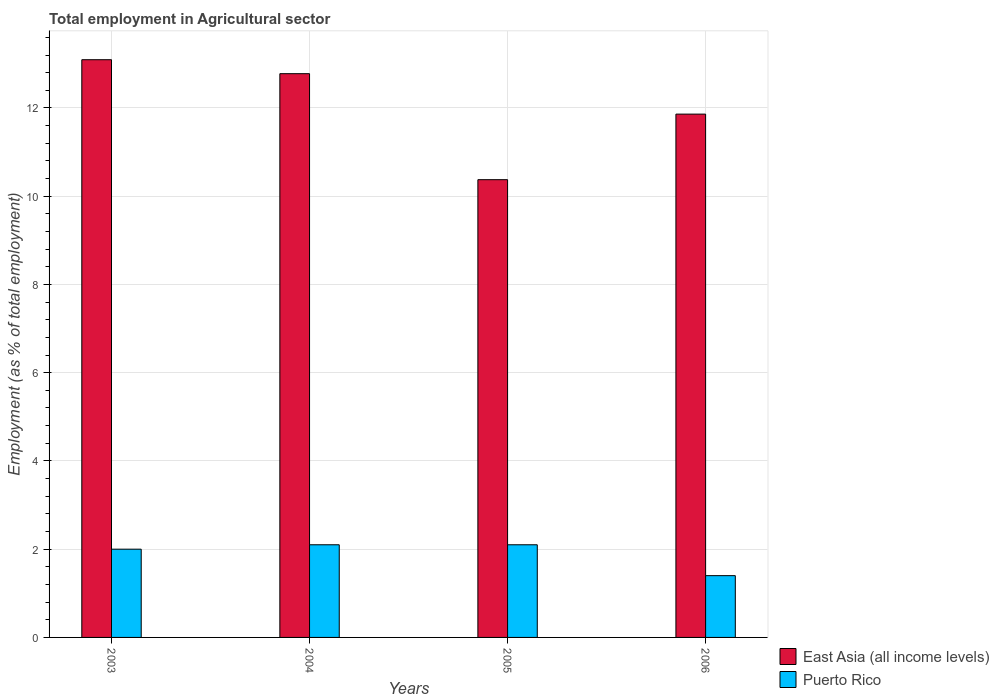How many groups of bars are there?
Give a very brief answer. 4. Are the number of bars on each tick of the X-axis equal?
Offer a very short reply. Yes. How many bars are there on the 4th tick from the left?
Your answer should be very brief. 2. How many bars are there on the 2nd tick from the right?
Offer a terse response. 2. What is the label of the 4th group of bars from the left?
Provide a succinct answer. 2006. What is the employment in agricultural sector in Puerto Rico in 2004?
Provide a short and direct response. 2.1. Across all years, what is the maximum employment in agricultural sector in East Asia (all income levels)?
Provide a short and direct response. 13.09. Across all years, what is the minimum employment in agricultural sector in Puerto Rico?
Ensure brevity in your answer.  1.4. In which year was the employment in agricultural sector in East Asia (all income levels) minimum?
Make the answer very short. 2005. What is the total employment in agricultural sector in East Asia (all income levels) in the graph?
Your answer should be very brief. 48.11. What is the difference between the employment in agricultural sector in Puerto Rico in 2004 and that in 2006?
Your response must be concise. 0.7. What is the difference between the employment in agricultural sector in Puerto Rico in 2005 and the employment in agricultural sector in East Asia (all income levels) in 2004?
Keep it short and to the point. -10.68. What is the average employment in agricultural sector in Puerto Rico per year?
Ensure brevity in your answer.  1.9. In the year 2005, what is the difference between the employment in agricultural sector in East Asia (all income levels) and employment in agricultural sector in Puerto Rico?
Make the answer very short. 8.27. In how many years, is the employment in agricultural sector in East Asia (all income levels) greater than 8.4 %?
Give a very brief answer. 4. What is the ratio of the employment in agricultural sector in East Asia (all income levels) in 2003 to that in 2006?
Provide a short and direct response. 1.1. Is the employment in agricultural sector in East Asia (all income levels) in 2004 less than that in 2006?
Offer a terse response. No. What is the difference between the highest and the second highest employment in agricultural sector in East Asia (all income levels)?
Give a very brief answer. 0.32. What is the difference between the highest and the lowest employment in agricultural sector in East Asia (all income levels)?
Ensure brevity in your answer.  2.72. In how many years, is the employment in agricultural sector in Puerto Rico greater than the average employment in agricultural sector in Puerto Rico taken over all years?
Keep it short and to the point. 3. Is the sum of the employment in agricultural sector in Puerto Rico in 2004 and 2006 greater than the maximum employment in agricultural sector in East Asia (all income levels) across all years?
Your answer should be very brief. No. What does the 2nd bar from the left in 2006 represents?
Keep it short and to the point. Puerto Rico. What does the 2nd bar from the right in 2003 represents?
Provide a short and direct response. East Asia (all income levels). How many years are there in the graph?
Offer a terse response. 4. Does the graph contain grids?
Provide a short and direct response. Yes. Where does the legend appear in the graph?
Your response must be concise. Bottom right. How many legend labels are there?
Your response must be concise. 2. How are the legend labels stacked?
Provide a short and direct response. Vertical. What is the title of the graph?
Give a very brief answer. Total employment in Agricultural sector. What is the label or title of the X-axis?
Your response must be concise. Years. What is the label or title of the Y-axis?
Make the answer very short. Employment (as % of total employment). What is the Employment (as % of total employment) of East Asia (all income levels) in 2003?
Make the answer very short. 13.09. What is the Employment (as % of total employment) of Puerto Rico in 2003?
Your answer should be very brief. 2. What is the Employment (as % of total employment) in East Asia (all income levels) in 2004?
Offer a terse response. 12.78. What is the Employment (as % of total employment) in Puerto Rico in 2004?
Offer a very short reply. 2.1. What is the Employment (as % of total employment) in East Asia (all income levels) in 2005?
Your response must be concise. 10.37. What is the Employment (as % of total employment) in Puerto Rico in 2005?
Your answer should be compact. 2.1. What is the Employment (as % of total employment) of East Asia (all income levels) in 2006?
Keep it short and to the point. 11.86. What is the Employment (as % of total employment) of Puerto Rico in 2006?
Your response must be concise. 1.4. Across all years, what is the maximum Employment (as % of total employment) of East Asia (all income levels)?
Offer a terse response. 13.09. Across all years, what is the maximum Employment (as % of total employment) in Puerto Rico?
Your answer should be compact. 2.1. Across all years, what is the minimum Employment (as % of total employment) of East Asia (all income levels)?
Offer a very short reply. 10.37. Across all years, what is the minimum Employment (as % of total employment) in Puerto Rico?
Your response must be concise. 1.4. What is the total Employment (as % of total employment) of East Asia (all income levels) in the graph?
Your answer should be compact. 48.11. What is the difference between the Employment (as % of total employment) of East Asia (all income levels) in 2003 and that in 2004?
Your answer should be very brief. 0.32. What is the difference between the Employment (as % of total employment) in Puerto Rico in 2003 and that in 2004?
Provide a short and direct response. -0.1. What is the difference between the Employment (as % of total employment) of East Asia (all income levels) in 2003 and that in 2005?
Provide a short and direct response. 2.72. What is the difference between the Employment (as % of total employment) in Puerto Rico in 2003 and that in 2005?
Ensure brevity in your answer.  -0.1. What is the difference between the Employment (as % of total employment) of East Asia (all income levels) in 2003 and that in 2006?
Your answer should be very brief. 1.23. What is the difference between the Employment (as % of total employment) in Puerto Rico in 2003 and that in 2006?
Ensure brevity in your answer.  0.6. What is the difference between the Employment (as % of total employment) in East Asia (all income levels) in 2004 and that in 2005?
Give a very brief answer. 2.4. What is the difference between the Employment (as % of total employment) of East Asia (all income levels) in 2004 and that in 2006?
Keep it short and to the point. 0.92. What is the difference between the Employment (as % of total employment) in East Asia (all income levels) in 2005 and that in 2006?
Provide a short and direct response. -1.49. What is the difference between the Employment (as % of total employment) of Puerto Rico in 2005 and that in 2006?
Keep it short and to the point. 0.7. What is the difference between the Employment (as % of total employment) in East Asia (all income levels) in 2003 and the Employment (as % of total employment) in Puerto Rico in 2004?
Keep it short and to the point. 10.99. What is the difference between the Employment (as % of total employment) in East Asia (all income levels) in 2003 and the Employment (as % of total employment) in Puerto Rico in 2005?
Ensure brevity in your answer.  10.99. What is the difference between the Employment (as % of total employment) of East Asia (all income levels) in 2003 and the Employment (as % of total employment) of Puerto Rico in 2006?
Your response must be concise. 11.69. What is the difference between the Employment (as % of total employment) in East Asia (all income levels) in 2004 and the Employment (as % of total employment) in Puerto Rico in 2005?
Provide a short and direct response. 10.68. What is the difference between the Employment (as % of total employment) of East Asia (all income levels) in 2004 and the Employment (as % of total employment) of Puerto Rico in 2006?
Provide a succinct answer. 11.38. What is the difference between the Employment (as % of total employment) of East Asia (all income levels) in 2005 and the Employment (as % of total employment) of Puerto Rico in 2006?
Provide a short and direct response. 8.97. What is the average Employment (as % of total employment) in East Asia (all income levels) per year?
Provide a succinct answer. 12.03. What is the average Employment (as % of total employment) of Puerto Rico per year?
Your response must be concise. 1.9. In the year 2003, what is the difference between the Employment (as % of total employment) of East Asia (all income levels) and Employment (as % of total employment) of Puerto Rico?
Give a very brief answer. 11.09. In the year 2004, what is the difference between the Employment (as % of total employment) of East Asia (all income levels) and Employment (as % of total employment) of Puerto Rico?
Provide a succinct answer. 10.68. In the year 2005, what is the difference between the Employment (as % of total employment) in East Asia (all income levels) and Employment (as % of total employment) in Puerto Rico?
Ensure brevity in your answer.  8.27. In the year 2006, what is the difference between the Employment (as % of total employment) in East Asia (all income levels) and Employment (as % of total employment) in Puerto Rico?
Your answer should be compact. 10.46. What is the ratio of the Employment (as % of total employment) of East Asia (all income levels) in 2003 to that in 2004?
Provide a succinct answer. 1.02. What is the ratio of the Employment (as % of total employment) of East Asia (all income levels) in 2003 to that in 2005?
Your answer should be compact. 1.26. What is the ratio of the Employment (as % of total employment) in Puerto Rico in 2003 to that in 2005?
Give a very brief answer. 0.95. What is the ratio of the Employment (as % of total employment) in East Asia (all income levels) in 2003 to that in 2006?
Offer a very short reply. 1.1. What is the ratio of the Employment (as % of total employment) in Puerto Rico in 2003 to that in 2006?
Provide a succinct answer. 1.43. What is the ratio of the Employment (as % of total employment) in East Asia (all income levels) in 2004 to that in 2005?
Provide a short and direct response. 1.23. What is the ratio of the Employment (as % of total employment) of Puerto Rico in 2004 to that in 2005?
Your response must be concise. 1. What is the ratio of the Employment (as % of total employment) in East Asia (all income levels) in 2004 to that in 2006?
Give a very brief answer. 1.08. What is the ratio of the Employment (as % of total employment) in East Asia (all income levels) in 2005 to that in 2006?
Give a very brief answer. 0.87. What is the ratio of the Employment (as % of total employment) of Puerto Rico in 2005 to that in 2006?
Give a very brief answer. 1.5. What is the difference between the highest and the second highest Employment (as % of total employment) in East Asia (all income levels)?
Offer a very short reply. 0.32. What is the difference between the highest and the second highest Employment (as % of total employment) in Puerto Rico?
Give a very brief answer. 0. What is the difference between the highest and the lowest Employment (as % of total employment) of East Asia (all income levels)?
Your answer should be very brief. 2.72. 